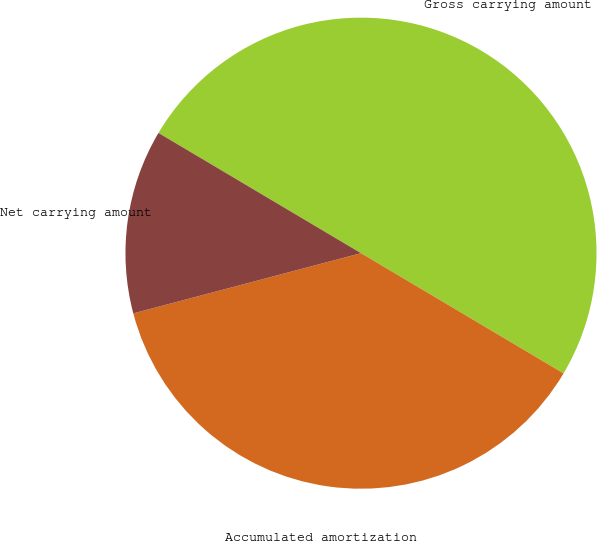Convert chart to OTSL. <chart><loc_0><loc_0><loc_500><loc_500><pie_chart><fcel>Gross carrying amount<fcel>Accumulated amortization<fcel>Net carrying amount<nl><fcel>50.0%<fcel>37.36%<fcel>12.64%<nl></chart> 